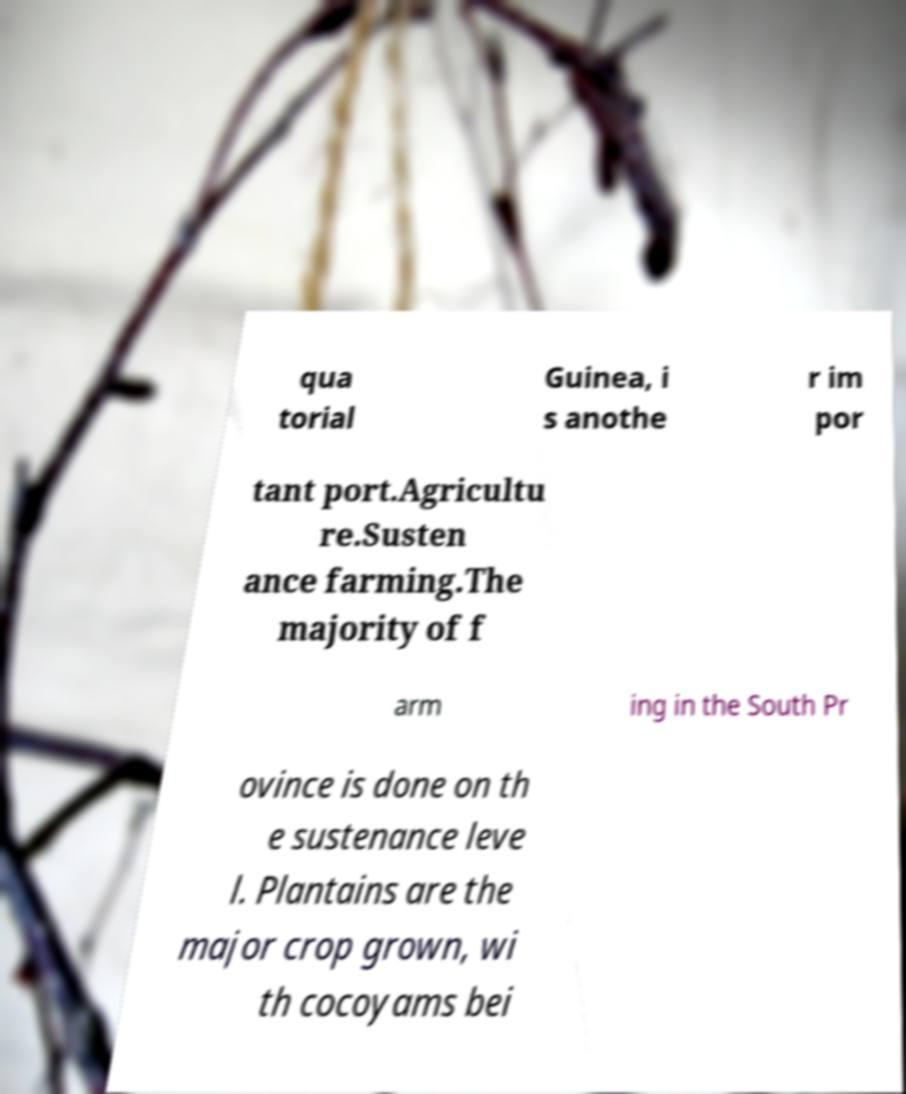Could you extract and type out the text from this image? qua torial Guinea, i s anothe r im por tant port.Agricultu re.Susten ance farming.The majority of f arm ing in the South Pr ovince is done on th e sustenance leve l. Plantains are the major crop grown, wi th cocoyams bei 